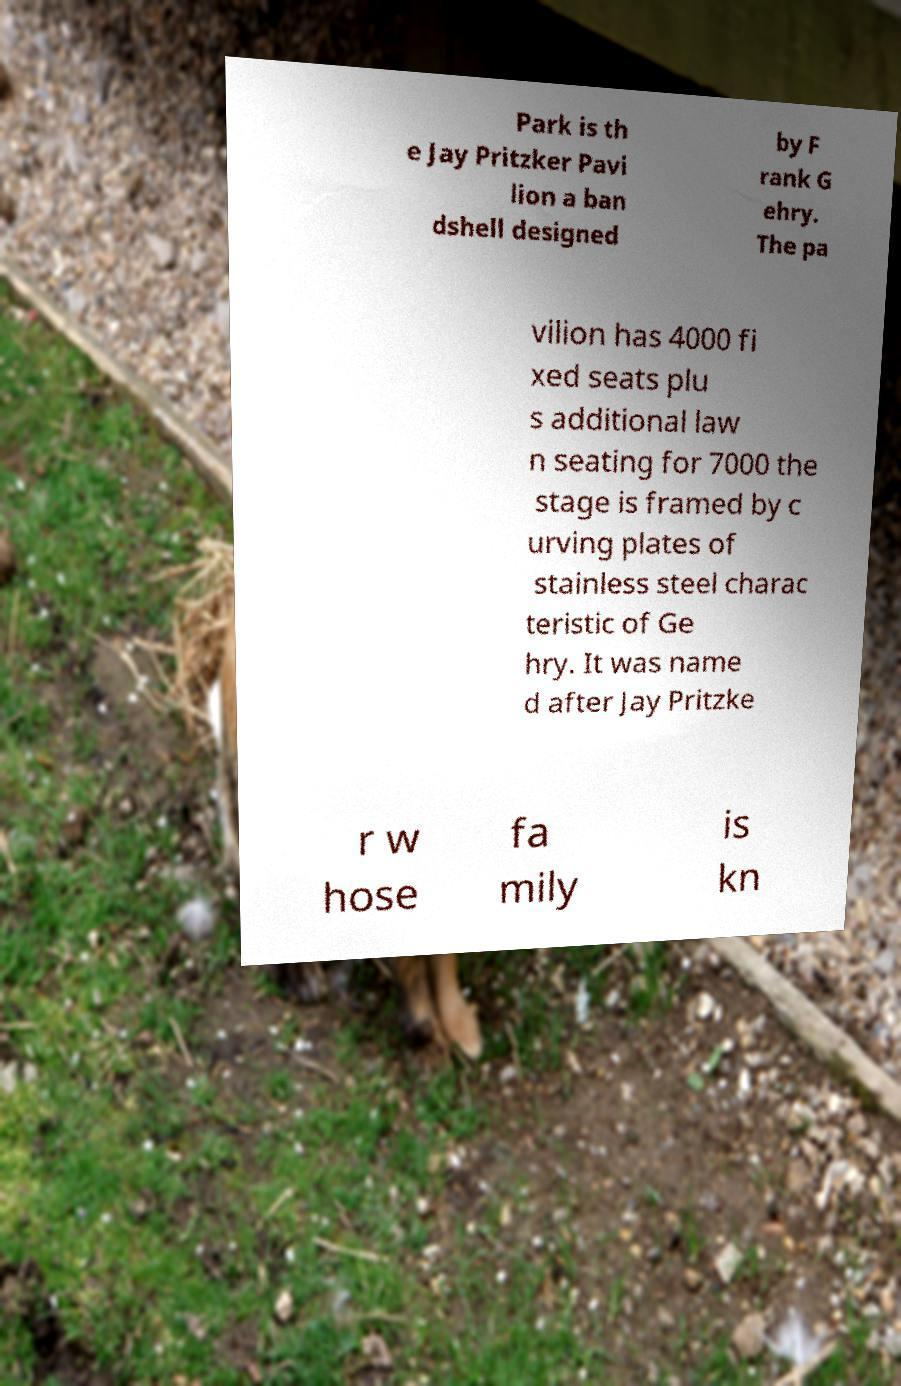Please read and relay the text visible in this image. What does it say? Park is th e Jay Pritzker Pavi lion a ban dshell designed by F rank G ehry. The pa vilion has 4000 fi xed seats plu s additional law n seating for 7000 the stage is framed by c urving plates of stainless steel charac teristic of Ge hry. It was name d after Jay Pritzke r w hose fa mily is kn 